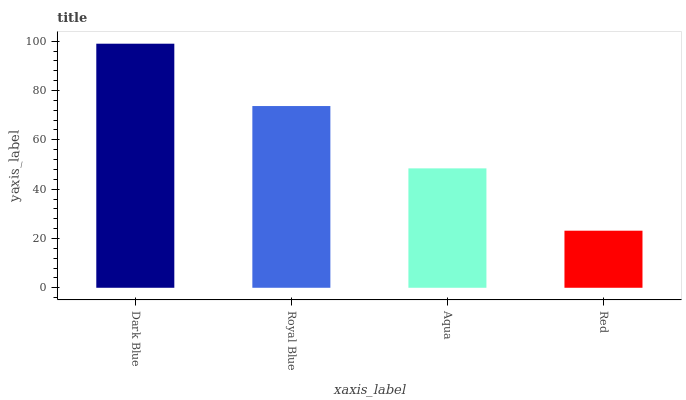Is Red the minimum?
Answer yes or no. Yes. Is Dark Blue the maximum?
Answer yes or no. Yes. Is Royal Blue the minimum?
Answer yes or no. No. Is Royal Blue the maximum?
Answer yes or no. No. Is Dark Blue greater than Royal Blue?
Answer yes or no. Yes. Is Royal Blue less than Dark Blue?
Answer yes or no. Yes. Is Royal Blue greater than Dark Blue?
Answer yes or no. No. Is Dark Blue less than Royal Blue?
Answer yes or no. No. Is Royal Blue the high median?
Answer yes or no. Yes. Is Aqua the low median?
Answer yes or no. Yes. Is Red the high median?
Answer yes or no. No. Is Dark Blue the low median?
Answer yes or no. No. 